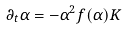<formula> <loc_0><loc_0><loc_500><loc_500>\partial _ { t } \alpha = - \alpha ^ { 2 } f ( \alpha ) K</formula> 